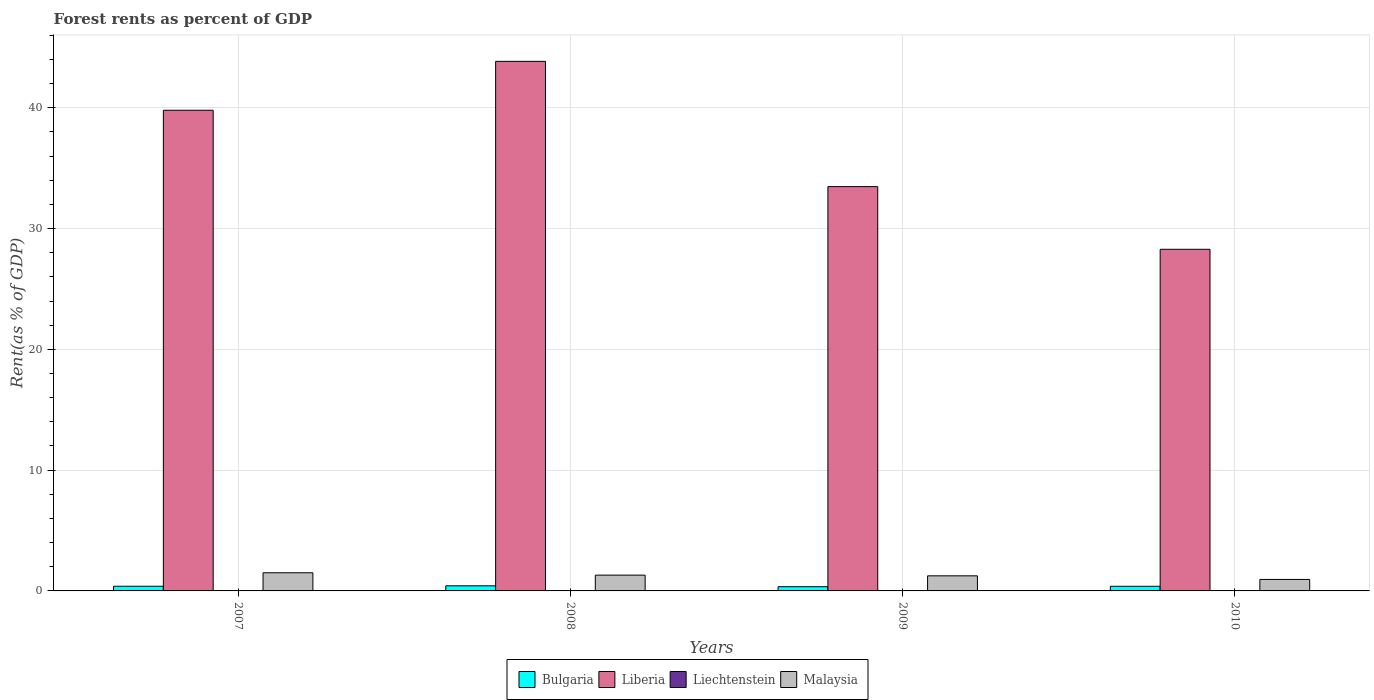Are the number of bars on each tick of the X-axis equal?
Provide a short and direct response. Yes. How many bars are there on the 4th tick from the left?
Provide a short and direct response. 4. What is the forest rent in Malaysia in 2010?
Offer a terse response. 0.95. Across all years, what is the maximum forest rent in Liberia?
Your answer should be very brief. 43.85. Across all years, what is the minimum forest rent in Bulgaria?
Provide a short and direct response. 0.35. In which year was the forest rent in Bulgaria maximum?
Ensure brevity in your answer.  2008. In which year was the forest rent in Bulgaria minimum?
Provide a short and direct response. 2009. What is the total forest rent in Malaysia in the graph?
Give a very brief answer. 5.01. What is the difference between the forest rent in Malaysia in 2008 and that in 2010?
Offer a very short reply. 0.36. What is the difference between the forest rent in Bulgaria in 2008 and the forest rent in Liechtenstein in 2007?
Ensure brevity in your answer.  0.4. What is the average forest rent in Malaysia per year?
Your response must be concise. 1.25. In the year 2008, what is the difference between the forest rent in Malaysia and forest rent in Liberia?
Give a very brief answer. -42.54. What is the ratio of the forest rent in Malaysia in 2007 to that in 2010?
Give a very brief answer. 1.58. Is the forest rent in Bulgaria in 2007 less than that in 2010?
Ensure brevity in your answer.  No. Is the difference between the forest rent in Malaysia in 2007 and 2008 greater than the difference between the forest rent in Liberia in 2007 and 2008?
Your answer should be compact. Yes. What is the difference between the highest and the second highest forest rent in Malaysia?
Your response must be concise. 0.2. What is the difference between the highest and the lowest forest rent in Bulgaria?
Make the answer very short. 0.07. In how many years, is the forest rent in Malaysia greater than the average forest rent in Malaysia taken over all years?
Provide a succinct answer. 2. Is it the case that in every year, the sum of the forest rent in Liechtenstein and forest rent in Bulgaria is greater than the sum of forest rent in Liberia and forest rent in Malaysia?
Keep it short and to the point. No. What does the 4th bar from the left in 2007 represents?
Your answer should be compact. Malaysia. How many bars are there?
Offer a very short reply. 16. Are all the bars in the graph horizontal?
Your response must be concise. No. How many years are there in the graph?
Make the answer very short. 4. What is the difference between two consecutive major ticks on the Y-axis?
Give a very brief answer. 10. Are the values on the major ticks of Y-axis written in scientific E-notation?
Your response must be concise. No. Does the graph contain grids?
Make the answer very short. Yes. How are the legend labels stacked?
Offer a very short reply. Horizontal. What is the title of the graph?
Provide a succinct answer. Forest rents as percent of GDP. Does "Japan" appear as one of the legend labels in the graph?
Offer a very short reply. No. What is the label or title of the Y-axis?
Keep it short and to the point. Rent(as % of GDP). What is the Rent(as % of GDP) in Bulgaria in 2007?
Give a very brief answer. 0.39. What is the Rent(as % of GDP) of Liberia in 2007?
Your response must be concise. 39.8. What is the Rent(as % of GDP) of Liechtenstein in 2007?
Ensure brevity in your answer.  0.02. What is the Rent(as % of GDP) in Malaysia in 2007?
Your answer should be very brief. 1.5. What is the Rent(as % of GDP) of Bulgaria in 2008?
Keep it short and to the point. 0.42. What is the Rent(as % of GDP) in Liberia in 2008?
Provide a succinct answer. 43.85. What is the Rent(as % of GDP) in Liechtenstein in 2008?
Provide a short and direct response. 0.03. What is the Rent(as % of GDP) in Malaysia in 2008?
Provide a short and direct response. 1.31. What is the Rent(as % of GDP) in Bulgaria in 2009?
Your answer should be compact. 0.35. What is the Rent(as % of GDP) of Liberia in 2009?
Ensure brevity in your answer.  33.48. What is the Rent(as % of GDP) in Liechtenstein in 2009?
Make the answer very short. 0.02. What is the Rent(as % of GDP) in Malaysia in 2009?
Give a very brief answer. 1.25. What is the Rent(as % of GDP) of Bulgaria in 2010?
Your answer should be very brief. 0.38. What is the Rent(as % of GDP) in Liberia in 2010?
Your answer should be compact. 28.29. What is the Rent(as % of GDP) in Liechtenstein in 2010?
Your response must be concise. 0.03. What is the Rent(as % of GDP) in Malaysia in 2010?
Keep it short and to the point. 0.95. Across all years, what is the maximum Rent(as % of GDP) in Bulgaria?
Ensure brevity in your answer.  0.42. Across all years, what is the maximum Rent(as % of GDP) of Liberia?
Your answer should be very brief. 43.85. Across all years, what is the maximum Rent(as % of GDP) of Liechtenstein?
Ensure brevity in your answer.  0.03. Across all years, what is the maximum Rent(as % of GDP) in Malaysia?
Offer a very short reply. 1.5. Across all years, what is the minimum Rent(as % of GDP) in Bulgaria?
Ensure brevity in your answer.  0.35. Across all years, what is the minimum Rent(as % of GDP) of Liberia?
Keep it short and to the point. 28.29. Across all years, what is the minimum Rent(as % of GDP) of Liechtenstein?
Offer a very short reply. 0.02. Across all years, what is the minimum Rent(as % of GDP) in Malaysia?
Give a very brief answer. 0.95. What is the total Rent(as % of GDP) of Bulgaria in the graph?
Make the answer very short. 1.54. What is the total Rent(as % of GDP) in Liberia in the graph?
Your response must be concise. 145.41. What is the total Rent(as % of GDP) in Liechtenstein in the graph?
Your answer should be compact. 0.11. What is the total Rent(as % of GDP) of Malaysia in the graph?
Give a very brief answer. 5.01. What is the difference between the Rent(as % of GDP) in Bulgaria in 2007 and that in 2008?
Keep it short and to the point. -0.04. What is the difference between the Rent(as % of GDP) of Liberia in 2007 and that in 2008?
Give a very brief answer. -4.05. What is the difference between the Rent(as % of GDP) in Liechtenstein in 2007 and that in 2008?
Your answer should be very brief. -0.01. What is the difference between the Rent(as % of GDP) of Malaysia in 2007 and that in 2008?
Your answer should be very brief. 0.2. What is the difference between the Rent(as % of GDP) in Bulgaria in 2007 and that in 2009?
Give a very brief answer. 0.04. What is the difference between the Rent(as % of GDP) in Liberia in 2007 and that in 2009?
Your answer should be compact. 6.32. What is the difference between the Rent(as % of GDP) of Malaysia in 2007 and that in 2009?
Make the answer very short. 0.25. What is the difference between the Rent(as % of GDP) in Bulgaria in 2007 and that in 2010?
Offer a terse response. 0. What is the difference between the Rent(as % of GDP) in Liberia in 2007 and that in 2010?
Your response must be concise. 11.51. What is the difference between the Rent(as % of GDP) in Liechtenstein in 2007 and that in 2010?
Your response must be concise. -0. What is the difference between the Rent(as % of GDP) of Malaysia in 2007 and that in 2010?
Offer a very short reply. 0.55. What is the difference between the Rent(as % of GDP) of Bulgaria in 2008 and that in 2009?
Provide a succinct answer. 0.07. What is the difference between the Rent(as % of GDP) in Liberia in 2008 and that in 2009?
Your answer should be very brief. 10.37. What is the difference between the Rent(as % of GDP) of Liechtenstein in 2008 and that in 2009?
Your answer should be very brief. 0.01. What is the difference between the Rent(as % of GDP) in Malaysia in 2008 and that in 2009?
Offer a very short reply. 0.06. What is the difference between the Rent(as % of GDP) of Bulgaria in 2008 and that in 2010?
Make the answer very short. 0.04. What is the difference between the Rent(as % of GDP) in Liberia in 2008 and that in 2010?
Your response must be concise. 15.56. What is the difference between the Rent(as % of GDP) of Liechtenstein in 2008 and that in 2010?
Your answer should be very brief. 0.01. What is the difference between the Rent(as % of GDP) in Malaysia in 2008 and that in 2010?
Your answer should be compact. 0.36. What is the difference between the Rent(as % of GDP) of Bulgaria in 2009 and that in 2010?
Ensure brevity in your answer.  -0.03. What is the difference between the Rent(as % of GDP) of Liberia in 2009 and that in 2010?
Give a very brief answer. 5.19. What is the difference between the Rent(as % of GDP) in Liechtenstein in 2009 and that in 2010?
Your response must be concise. -0. What is the difference between the Rent(as % of GDP) in Malaysia in 2009 and that in 2010?
Provide a short and direct response. 0.3. What is the difference between the Rent(as % of GDP) of Bulgaria in 2007 and the Rent(as % of GDP) of Liberia in 2008?
Offer a very short reply. -43.46. What is the difference between the Rent(as % of GDP) of Bulgaria in 2007 and the Rent(as % of GDP) of Liechtenstein in 2008?
Ensure brevity in your answer.  0.35. What is the difference between the Rent(as % of GDP) of Bulgaria in 2007 and the Rent(as % of GDP) of Malaysia in 2008?
Give a very brief answer. -0.92. What is the difference between the Rent(as % of GDP) in Liberia in 2007 and the Rent(as % of GDP) in Liechtenstein in 2008?
Give a very brief answer. 39.77. What is the difference between the Rent(as % of GDP) in Liberia in 2007 and the Rent(as % of GDP) in Malaysia in 2008?
Your answer should be compact. 38.49. What is the difference between the Rent(as % of GDP) of Liechtenstein in 2007 and the Rent(as % of GDP) of Malaysia in 2008?
Offer a terse response. -1.28. What is the difference between the Rent(as % of GDP) of Bulgaria in 2007 and the Rent(as % of GDP) of Liberia in 2009?
Ensure brevity in your answer.  -33.09. What is the difference between the Rent(as % of GDP) in Bulgaria in 2007 and the Rent(as % of GDP) in Liechtenstein in 2009?
Keep it short and to the point. 0.36. What is the difference between the Rent(as % of GDP) of Bulgaria in 2007 and the Rent(as % of GDP) of Malaysia in 2009?
Give a very brief answer. -0.86. What is the difference between the Rent(as % of GDP) in Liberia in 2007 and the Rent(as % of GDP) in Liechtenstein in 2009?
Keep it short and to the point. 39.77. What is the difference between the Rent(as % of GDP) of Liberia in 2007 and the Rent(as % of GDP) of Malaysia in 2009?
Ensure brevity in your answer.  38.55. What is the difference between the Rent(as % of GDP) of Liechtenstein in 2007 and the Rent(as % of GDP) of Malaysia in 2009?
Offer a very short reply. -1.22. What is the difference between the Rent(as % of GDP) of Bulgaria in 2007 and the Rent(as % of GDP) of Liberia in 2010?
Offer a terse response. -27.9. What is the difference between the Rent(as % of GDP) in Bulgaria in 2007 and the Rent(as % of GDP) in Liechtenstein in 2010?
Provide a short and direct response. 0.36. What is the difference between the Rent(as % of GDP) in Bulgaria in 2007 and the Rent(as % of GDP) in Malaysia in 2010?
Provide a short and direct response. -0.57. What is the difference between the Rent(as % of GDP) in Liberia in 2007 and the Rent(as % of GDP) in Liechtenstein in 2010?
Ensure brevity in your answer.  39.77. What is the difference between the Rent(as % of GDP) in Liberia in 2007 and the Rent(as % of GDP) in Malaysia in 2010?
Your answer should be compact. 38.85. What is the difference between the Rent(as % of GDP) in Liechtenstein in 2007 and the Rent(as % of GDP) in Malaysia in 2010?
Provide a short and direct response. -0.93. What is the difference between the Rent(as % of GDP) of Bulgaria in 2008 and the Rent(as % of GDP) of Liberia in 2009?
Ensure brevity in your answer.  -33.05. What is the difference between the Rent(as % of GDP) of Bulgaria in 2008 and the Rent(as % of GDP) of Liechtenstein in 2009?
Provide a short and direct response. 0.4. What is the difference between the Rent(as % of GDP) in Bulgaria in 2008 and the Rent(as % of GDP) in Malaysia in 2009?
Your answer should be compact. -0.83. What is the difference between the Rent(as % of GDP) of Liberia in 2008 and the Rent(as % of GDP) of Liechtenstein in 2009?
Your response must be concise. 43.82. What is the difference between the Rent(as % of GDP) in Liberia in 2008 and the Rent(as % of GDP) in Malaysia in 2009?
Provide a succinct answer. 42.6. What is the difference between the Rent(as % of GDP) of Liechtenstein in 2008 and the Rent(as % of GDP) of Malaysia in 2009?
Keep it short and to the point. -1.22. What is the difference between the Rent(as % of GDP) of Bulgaria in 2008 and the Rent(as % of GDP) of Liberia in 2010?
Make the answer very short. -27.86. What is the difference between the Rent(as % of GDP) in Bulgaria in 2008 and the Rent(as % of GDP) in Liechtenstein in 2010?
Your answer should be compact. 0.4. What is the difference between the Rent(as % of GDP) in Bulgaria in 2008 and the Rent(as % of GDP) in Malaysia in 2010?
Offer a terse response. -0.53. What is the difference between the Rent(as % of GDP) of Liberia in 2008 and the Rent(as % of GDP) of Liechtenstein in 2010?
Make the answer very short. 43.82. What is the difference between the Rent(as % of GDP) of Liberia in 2008 and the Rent(as % of GDP) of Malaysia in 2010?
Make the answer very short. 42.9. What is the difference between the Rent(as % of GDP) of Liechtenstein in 2008 and the Rent(as % of GDP) of Malaysia in 2010?
Make the answer very short. -0.92. What is the difference between the Rent(as % of GDP) in Bulgaria in 2009 and the Rent(as % of GDP) in Liberia in 2010?
Provide a short and direct response. -27.94. What is the difference between the Rent(as % of GDP) of Bulgaria in 2009 and the Rent(as % of GDP) of Liechtenstein in 2010?
Offer a terse response. 0.32. What is the difference between the Rent(as % of GDP) in Bulgaria in 2009 and the Rent(as % of GDP) in Malaysia in 2010?
Provide a succinct answer. -0.6. What is the difference between the Rent(as % of GDP) of Liberia in 2009 and the Rent(as % of GDP) of Liechtenstein in 2010?
Offer a terse response. 33.45. What is the difference between the Rent(as % of GDP) of Liberia in 2009 and the Rent(as % of GDP) of Malaysia in 2010?
Provide a succinct answer. 32.52. What is the difference between the Rent(as % of GDP) of Liechtenstein in 2009 and the Rent(as % of GDP) of Malaysia in 2010?
Your answer should be very brief. -0.93. What is the average Rent(as % of GDP) of Bulgaria per year?
Keep it short and to the point. 0.39. What is the average Rent(as % of GDP) in Liberia per year?
Offer a terse response. 36.35. What is the average Rent(as % of GDP) of Liechtenstein per year?
Provide a short and direct response. 0.03. What is the average Rent(as % of GDP) of Malaysia per year?
Offer a very short reply. 1.25. In the year 2007, what is the difference between the Rent(as % of GDP) of Bulgaria and Rent(as % of GDP) of Liberia?
Offer a terse response. -39.41. In the year 2007, what is the difference between the Rent(as % of GDP) of Bulgaria and Rent(as % of GDP) of Liechtenstein?
Offer a terse response. 0.36. In the year 2007, what is the difference between the Rent(as % of GDP) in Bulgaria and Rent(as % of GDP) in Malaysia?
Ensure brevity in your answer.  -1.12. In the year 2007, what is the difference between the Rent(as % of GDP) in Liberia and Rent(as % of GDP) in Liechtenstein?
Provide a short and direct response. 39.77. In the year 2007, what is the difference between the Rent(as % of GDP) in Liberia and Rent(as % of GDP) in Malaysia?
Provide a short and direct response. 38.3. In the year 2007, what is the difference between the Rent(as % of GDP) of Liechtenstein and Rent(as % of GDP) of Malaysia?
Offer a terse response. -1.48. In the year 2008, what is the difference between the Rent(as % of GDP) in Bulgaria and Rent(as % of GDP) in Liberia?
Give a very brief answer. -43.42. In the year 2008, what is the difference between the Rent(as % of GDP) of Bulgaria and Rent(as % of GDP) of Liechtenstein?
Offer a terse response. 0.39. In the year 2008, what is the difference between the Rent(as % of GDP) in Bulgaria and Rent(as % of GDP) in Malaysia?
Offer a very short reply. -0.88. In the year 2008, what is the difference between the Rent(as % of GDP) of Liberia and Rent(as % of GDP) of Liechtenstein?
Ensure brevity in your answer.  43.82. In the year 2008, what is the difference between the Rent(as % of GDP) in Liberia and Rent(as % of GDP) in Malaysia?
Your response must be concise. 42.54. In the year 2008, what is the difference between the Rent(as % of GDP) of Liechtenstein and Rent(as % of GDP) of Malaysia?
Keep it short and to the point. -1.28. In the year 2009, what is the difference between the Rent(as % of GDP) of Bulgaria and Rent(as % of GDP) of Liberia?
Provide a succinct answer. -33.12. In the year 2009, what is the difference between the Rent(as % of GDP) of Bulgaria and Rent(as % of GDP) of Liechtenstein?
Provide a short and direct response. 0.33. In the year 2009, what is the difference between the Rent(as % of GDP) in Bulgaria and Rent(as % of GDP) in Malaysia?
Provide a short and direct response. -0.9. In the year 2009, what is the difference between the Rent(as % of GDP) in Liberia and Rent(as % of GDP) in Liechtenstein?
Provide a short and direct response. 33.45. In the year 2009, what is the difference between the Rent(as % of GDP) of Liberia and Rent(as % of GDP) of Malaysia?
Give a very brief answer. 32.23. In the year 2009, what is the difference between the Rent(as % of GDP) in Liechtenstein and Rent(as % of GDP) in Malaysia?
Your answer should be compact. -1.23. In the year 2010, what is the difference between the Rent(as % of GDP) of Bulgaria and Rent(as % of GDP) of Liberia?
Provide a short and direct response. -27.9. In the year 2010, what is the difference between the Rent(as % of GDP) of Bulgaria and Rent(as % of GDP) of Liechtenstein?
Your answer should be very brief. 0.36. In the year 2010, what is the difference between the Rent(as % of GDP) of Bulgaria and Rent(as % of GDP) of Malaysia?
Your answer should be compact. -0.57. In the year 2010, what is the difference between the Rent(as % of GDP) of Liberia and Rent(as % of GDP) of Liechtenstein?
Your response must be concise. 28.26. In the year 2010, what is the difference between the Rent(as % of GDP) in Liberia and Rent(as % of GDP) in Malaysia?
Offer a very short reply. 27.33. In the year 2010, what is the difference between the Rent(as % of GDP) in Liechtenstein and Rent(as % of GDP) in Malaysia?
Your answer should be compact. -0.92. What is the ratio of the Rent(as % of GDP) of Bulgaria in 2007 to that in 2008?
Offer a very short reply. 0.91. What is the ratio of the Rent(as % of GDP) in Liberia in 2007 to that in 2008?
Provide a short and direct response. 0.91. What is the ratio of the Rent(as % of GDP) of Liechtenstein in 2007 to that in 2008?
Offer a very short reply. 0.78. What is the ratio of the Rent(as % of GDP) of Malaysia in 2007 to that in 2008?
Keep it short and to the point. 1.15. What is the ratio of the Rent(as % of GDP) in Bulgaria in 2007 to that in 2009?
Keep it short and to the point. 1.1. What is the ratio of the Rent(as % of GDP) of Liberia in 2007 to that in 2009?
Make the answer very short. 1.19. What is the ratio of the Rent(as % of GDP) of Liechtenstein in 2007 to that in 2009?
Make the answer very short. 1.02. What is the ratio of the Rent(as % of GDP) in Malaysia in 2007 to that in 2009?
Keep it short and to the point. 1.2. What is the ratio of the Rent(as % of GDP) in Liberia in 2007 to that in 2010?
Ensure brevity in your answer.  1.41. What is the ratio of the Rent(as % of GDP) of Liechtenstein in 2007 to that in 2010?
Give a very brief answer. 0.93. What is the ratio of the Rent(as % of GDP) in Malaysia in 2007 to that in 2010?
Your response must be concise. 1.58. What is the ratio of the Rent(as % of GDP) of Bulgaria in 2008 to that in 2009?
Your response must be concise. 1.21. What is the ratio of the Rent(as % of GDP) of Liberia in 2008 to that in 2009?
Ensure brevity in your answer.  1.31. What is the ratio of the Rent(as % of GDP) in Liechtenstein in 2008 to that in 2009?
Provide a short and direct response. 1.3. What is the ratio of the Rent(as % of GDP) of Malaysia in 2008 to that in 2009?
Your answer should be compact. 1.05. What is the ratio of the Rent(as % of GDP) in Bulgaria in 2008 to that in 2010?
Your answer should be very brief. 1.1. What is the ratio of the Rent(as % of GDP) of Liberia in 2008 to that in 2010?
Offer a very short reply. 1.55. What is the ratio of the Rent(as % of GDP) in Liechtenstein in 2008 to that in 2010?
Give a very brief answer. 1.19. What is the ratio of the Rent(as % of GDP) of Malaysia in 2008 to that in 2010?
Make the answer very short. 1.37. What is the ratio of the Rent(as % of GDP) in Bulgaria in 2009 to that in 2010?
Your answer should be compact. 0.91. What is the ratio of the Rent(as % of GDP) in Liberia in 2009 to that in 2010?
Your answer should be compact. 1.18. What is the ratio of the Rent(as % of GDP) in Liechtenstein in 2009 to that in 2010?
Offer a very short reply. 0.91. What is the ratio of the Rent(as % of GDP) in Malaysia in 2009 to that in 2010?
Give a very brief answer. 1.31. What is the difference between the highest and the second highest Rent(as % of GDP) of Bulgaria?
Your answer should be compact. 0.04. What is the difference between the highest and the second highest Rent(as % of GDP) in Liberia?
Offer a very short reply. 4.05. What is the difference between the highest and the second highest Rent(as % of GDP) in Liechtenstein?
Provide a succinct answer. 0.01. What is the difference between the highest and the second highest Rent(as % of GDP) in Malaysia?
Your answer should be compact. 0.2. What is the difference between the highest and the lowest Rent(as % of GDP) of Bulgaria?
Keep it short and to the point. 0.07. What is the difference between the highest and the lowest Rent(as % of GDP) of Liberia?
Keep it short and to the point. 15.56. What is the difference between the highest and the lowest Rent(as % of GDP) of Liechtenstein?
Your response must be concise. 0.01. What is the difference between the highest and the lowest Rent(as % of GDP) in Malaysia?
Your answer should be compact. 0.55. 